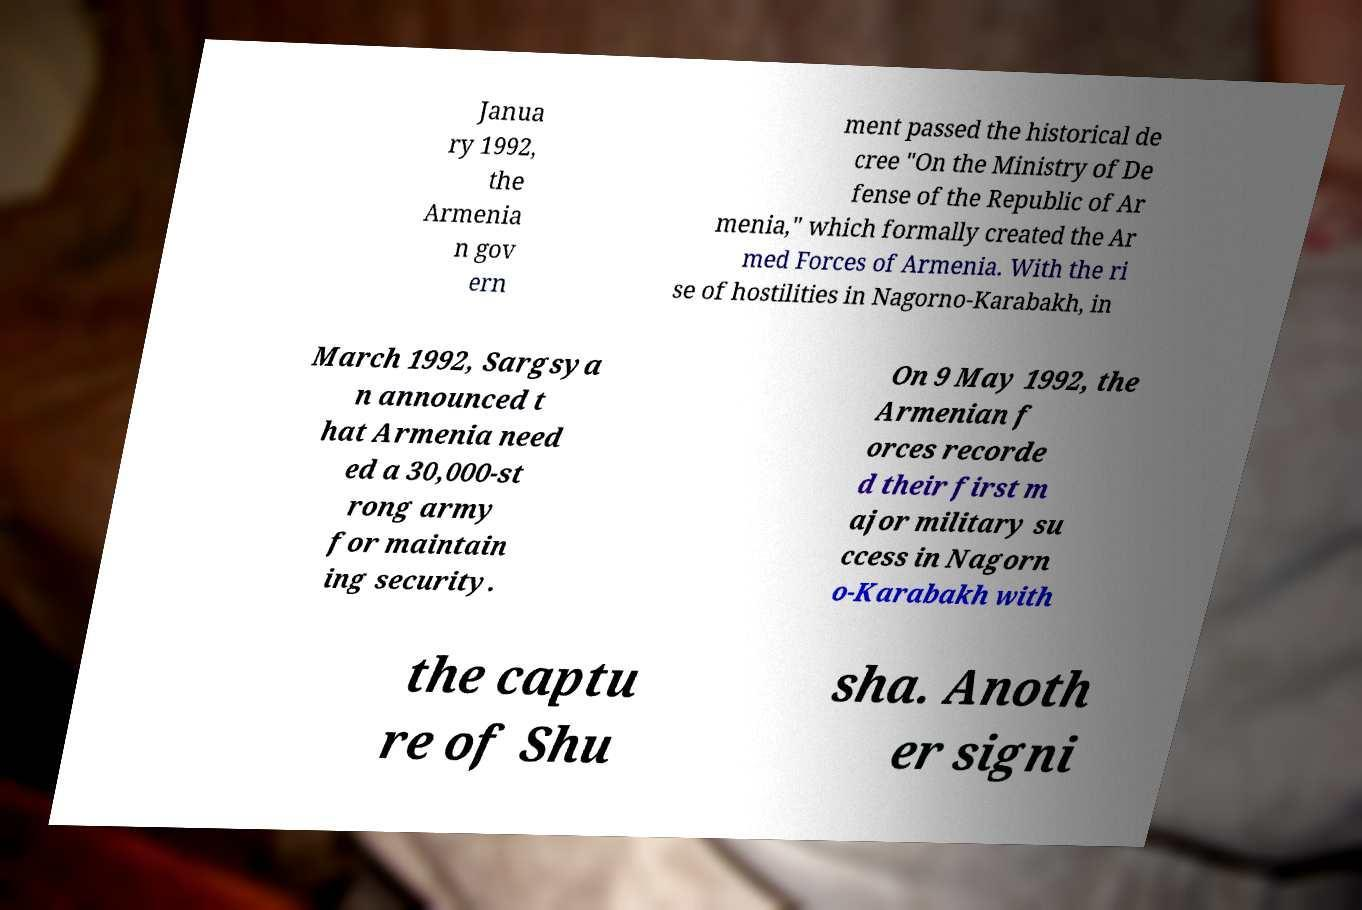I need the written content from this picture converted into text. Can you do that? Janua ry 1992, the Armenia n gov ern ment passed the historical de cree "On the Ministry of De fense of the Republic of Ar menia," which formally created the Ar med Forces of Armenia. With the ri se of hostilities in Nagorno-Karabakh, in March 1992, Sargsya n announced t hat Armenia need ed a 30,000-st rong army for maintain ing security. On 9 May 1992, the Armenian f orces recorde d their first m ajor military su ccess in Nagorn o-Karabakh with the captu re of Shu sha. Anoth er signi 